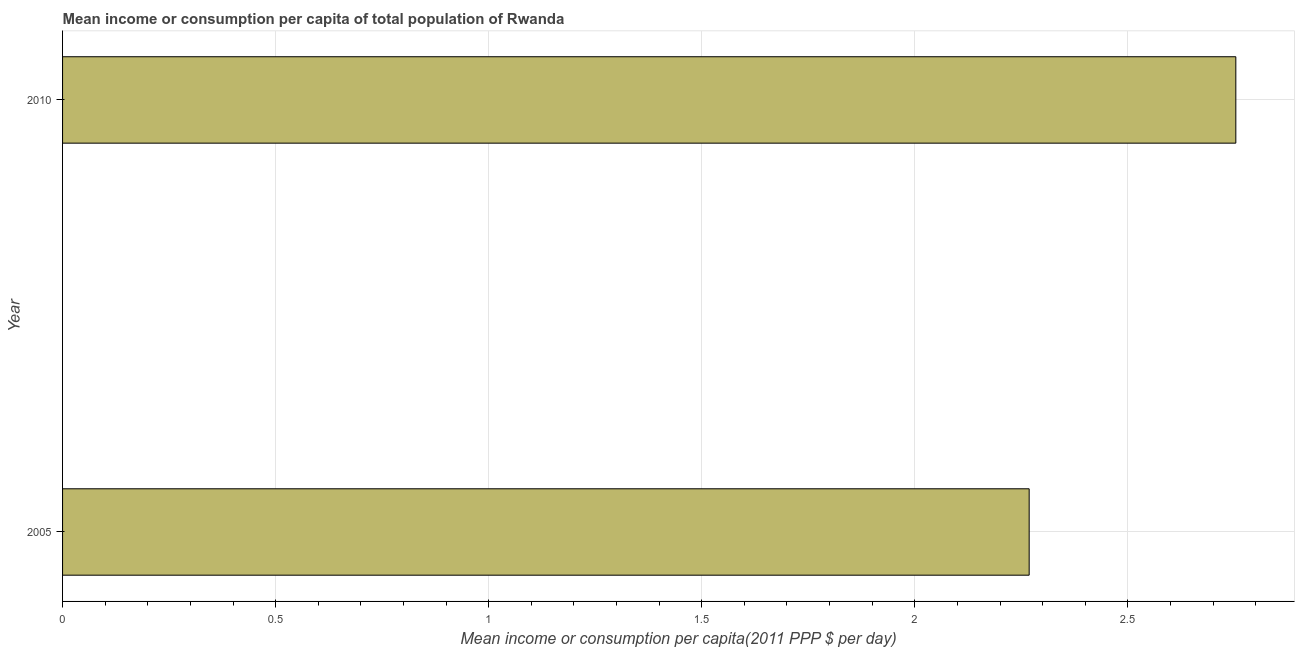Does the graph contain grids?
Your answer should be compact. Yes. What is the title of the graph?
Your answer should be compact. Mean income or consumption per capita of total population of Rwanda. What is the label or title of the X-axis?
Your answer should be compact. Mean income or consumption per capita(2011 PPP $ per day). What is the label or title of the Y-axis?
Make the answer very short. Year. What is the mean income or consumption in 2005?
Keep it short and to the point. 2.27. Across all years, what is the maximum mean income or consumption?
Offer a very short reply. 2.75. Across all years, what is the minimum mean income or consumption?
Give a very brief answer. 2.27. What is the sum of the mean income or consumption?
Your answer should be compact. 5.02. What is the difference between the mean income or consumption in 2005 and 2010?
Provide a succinct answer. -0.48. What is the average mean income or consumption per year?
Provide a short and direct response. 2.51. What is the median mean income or consumption?
Ensure brevity in your answer.  2.51. In how many years, is the mean income or consumption greater than 1.8 $?
Offer a terse response. 2. What is the ratio of the mean income or consumption in 2005 to that in 2010?
Ensure brevity in your answer.  0.82. In how many years, is the mean income or consumption greater than the average mean income or consumption taken over all years?
Provide a short and direct response. 1. Are all the bars in the graph horizontal?
Your response must be concise. Yes. How many years are there in the graph?
Your response must be concise. 2. What is the Mean income or consumption per capita(2011 PPP $ per day) of 2005?
Provide a succinct answer. 2.27. What is the Mean income or consumption per capita(2011 PPP $ per day) of 2010?
Give a very brief answer. 2.75. What is the difference between the Mean income or consumption per capita(2011 PPP $ per day) in 2005 and 2010?
Offer a terse response. -0.48. What is the ratio of the Mean income or consumption per capita(2011 PPP $ per day) in 2005 to that in 2010?
Offer a terse response. 0.82. 